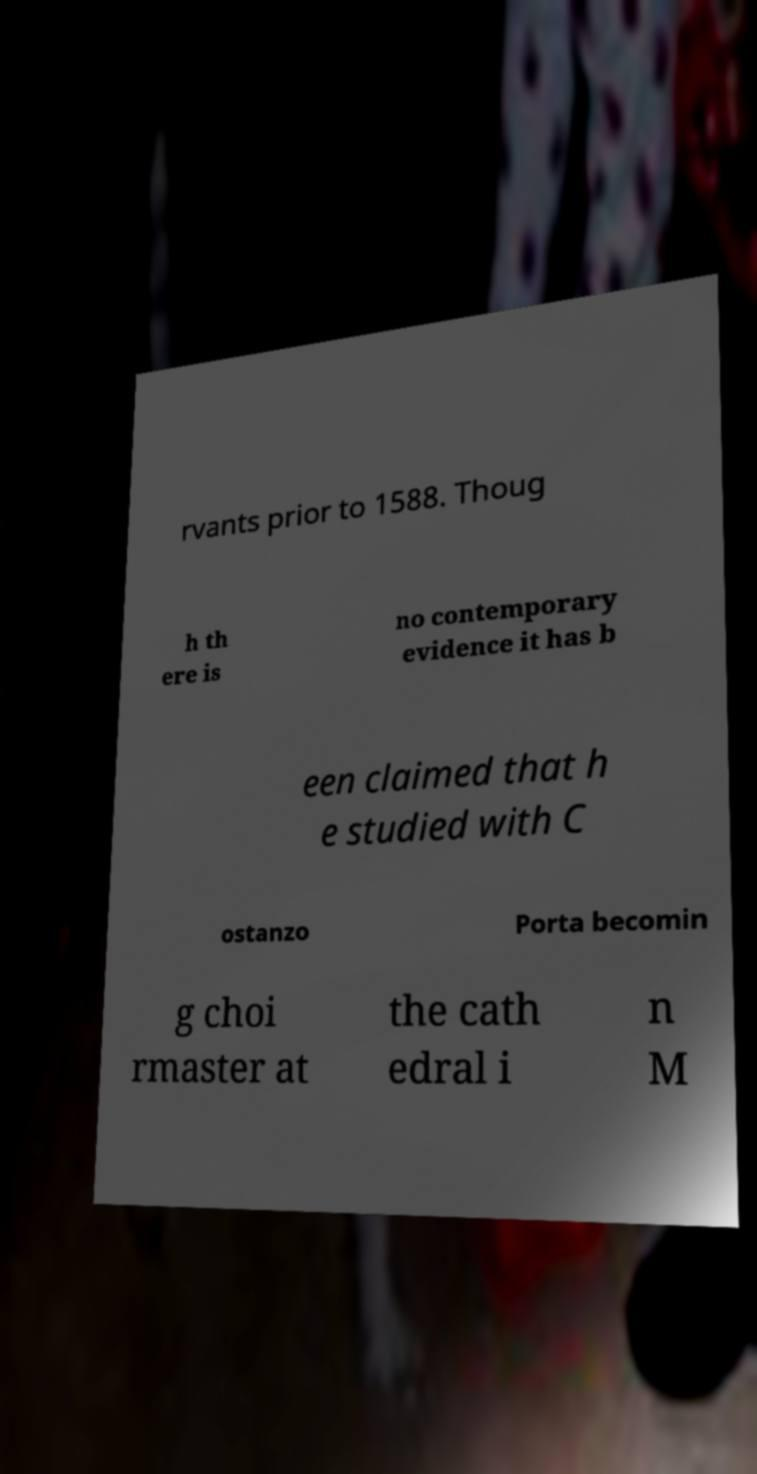What messages or text are displayed in this image? I need them in a readable, typed format. rvants prior to 1588. Thoug h th ere is no contemporary evidence it has b een claimed that h e studied with C ostanzo Porta becomin g choi rmaster at the cath edral i n M 